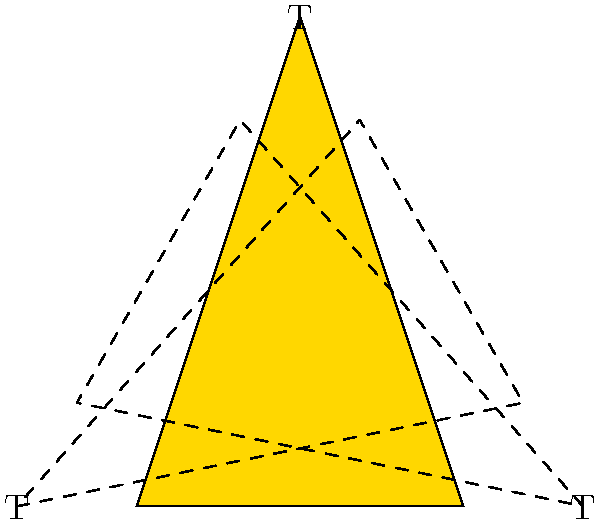At a Travis Tritt concert, you notice his guitar pick has a unique triangular design with his initial "T" on each side. Assuming the pick is perfectly equilateral, what is the order of the symmetry group for this design? To determine the order of the symmetry group for Travis Tritt's guitar pick design, we need to consider all the symmetries that leave the design unchanged. Let's analyze step-by-step:

1. Rotational symmetries:
   - 120° rotation (clockwise or counterclockwise)
   - 240° rotation (clockwise or counterclockwise)
   - 360° rotation (identity)
   Total rotational symmetries: 3

2. Reflection symmetries:
   - Reflection across the line from a vertex to the midpoint of the opposite side (3 lines of reflection)
   Total reflection symmetries: 3

3. Identity symmetry:
   - Leaving the pick unchanged
   Total identity symmetries: 1

The total number of symmetries is the sum of all these transformations:
$$ \text{Total symmetries} = 3 \text{ (rotations)} + 3 \text{ (reflections)} + 1 \text{ (identity)} = 7 $$

In group theory, the order of a group is the number of elements in the group. Therefore, the order of the symmetry group for this guitar pick design is 7.

This symmetry group is known as the dihedral group $D_3$, which is the group of symmetries of an equilateral triangle.
Answer: 6 